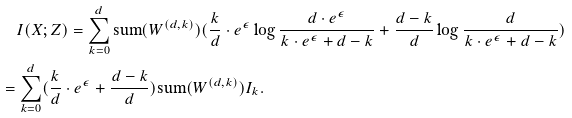<formula> <loc_0><loc_0><loc_500><loc_500>& \quad I ( X ; Z ) = \sum _ { k = 0 } ^ { d } \text {sum} ( W ^ { ( d , k ) } ) { ( \frac { k } { d } \cdot e ^ { \epsilon } \log { \frac { d \cdot e ^ { \epsilon } } { k \cdot e ^ { \epsilon } + d - k } } + \frac { d - k } { d } \log { \frac { d } { k \cdot e ^ { \epsilon } + d - k } } ) } & \\ & = \sum _ { k = 0 } ^ { d } ( \frac { k } { d } \cdot e ^ { \epsilon } + \frac { d - k } { d } ) \text {sum} ( W ^ { ( d , k ) } ) I _ { k } . & \\</formula> 